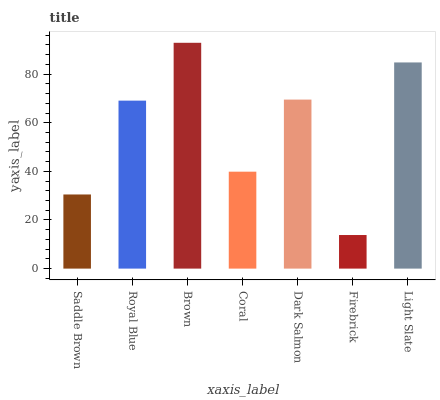Is Firebrick the minimum?
Answer yes or no. Yes. Is Brown the maximum?
Answer yes or no. Yes. Is Royal Blue the minimum?
Answer yes or no. No. Is Royal Blue the maximum?
Answer yes or no. No. Is Royal Blue greater than Saddle Brown?
Answer yes or no. Yes. Is Saddle Brown less than Royal Blue?
Answer yes or no. Yes. Is Saddle Brown greater than Royal Blue?
Answer yes or no. No. Is Royal Blue less than Saddle Brown?
Answer yes or no. No. Is Royal Blue the high median?
Answer yes or no. Yes. Is Royal Blue the low median?
Answer yes or no. Yes. Is Firebrick the high median?
Answer yes or no. No. Is Coral the low median?
Answer yes or no. No. 